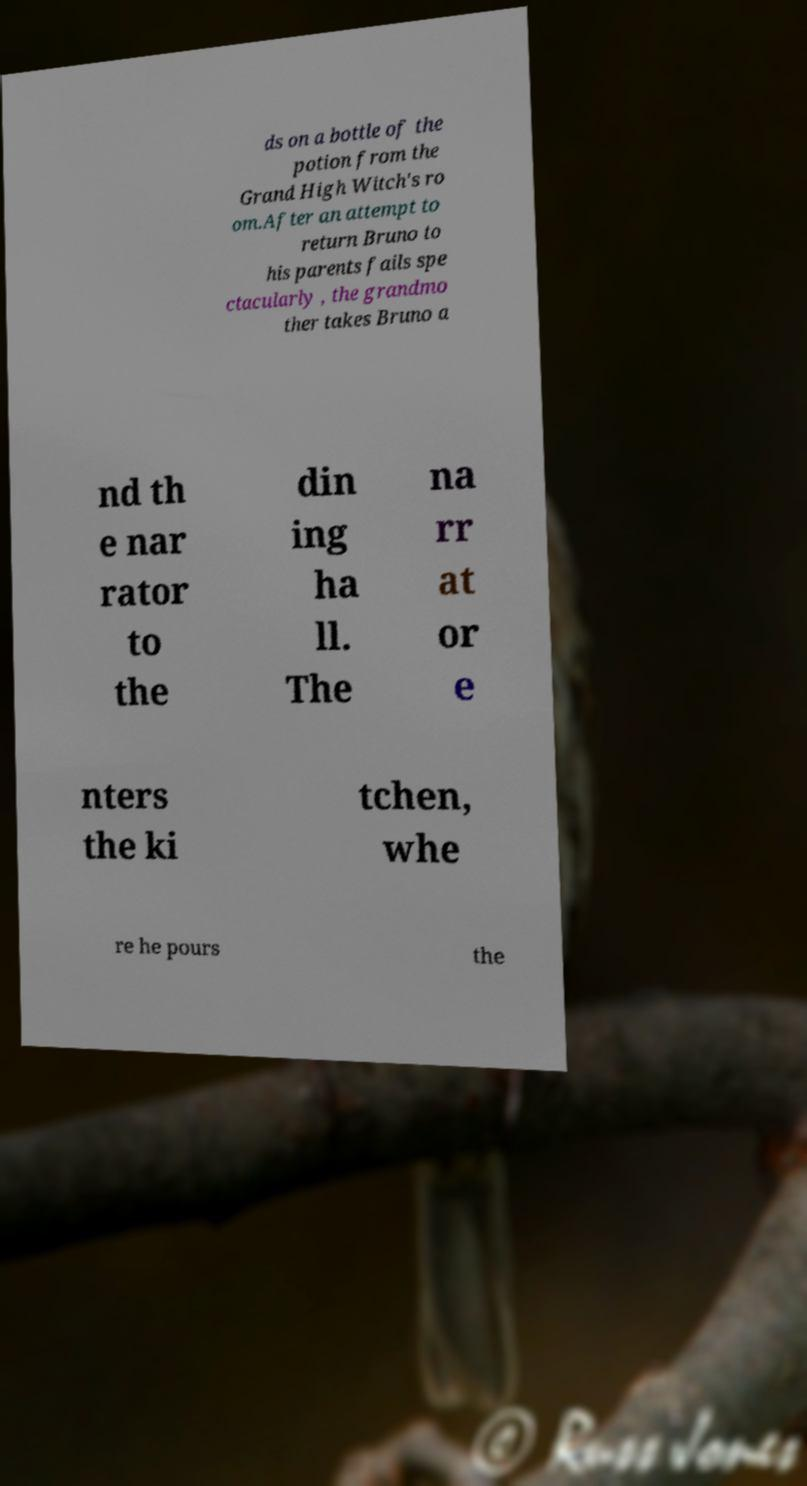Can you read and provide the text displayed in the image?This photo seems to have some interesting text. Can you extract and type it out for me? ds on a bottle of the potion from the Grand High Witch's ro om.After an attempt to return Bruno to his parents fails spe ctacularly , the grandmo ther takes Bruno a nd th e nar rator to the din ing ha ll. The na rr at or e nters the ki tchen, whe re he pours the 